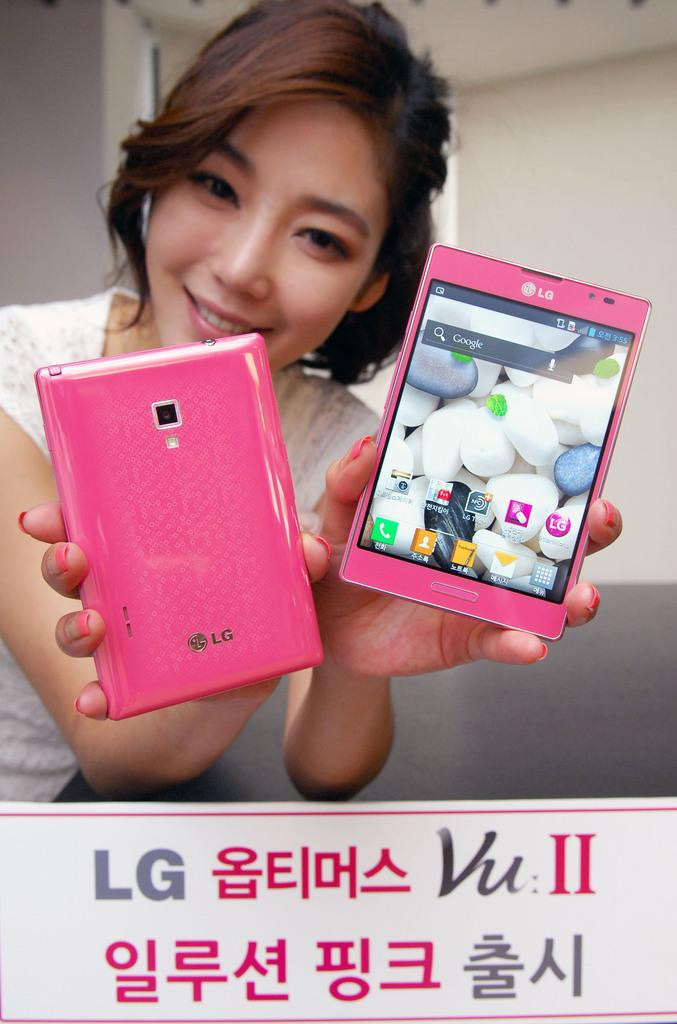<image>
Give a short and clear explanation of the subsequent image. Two pink LG cellular phones are displayed by a girl. 